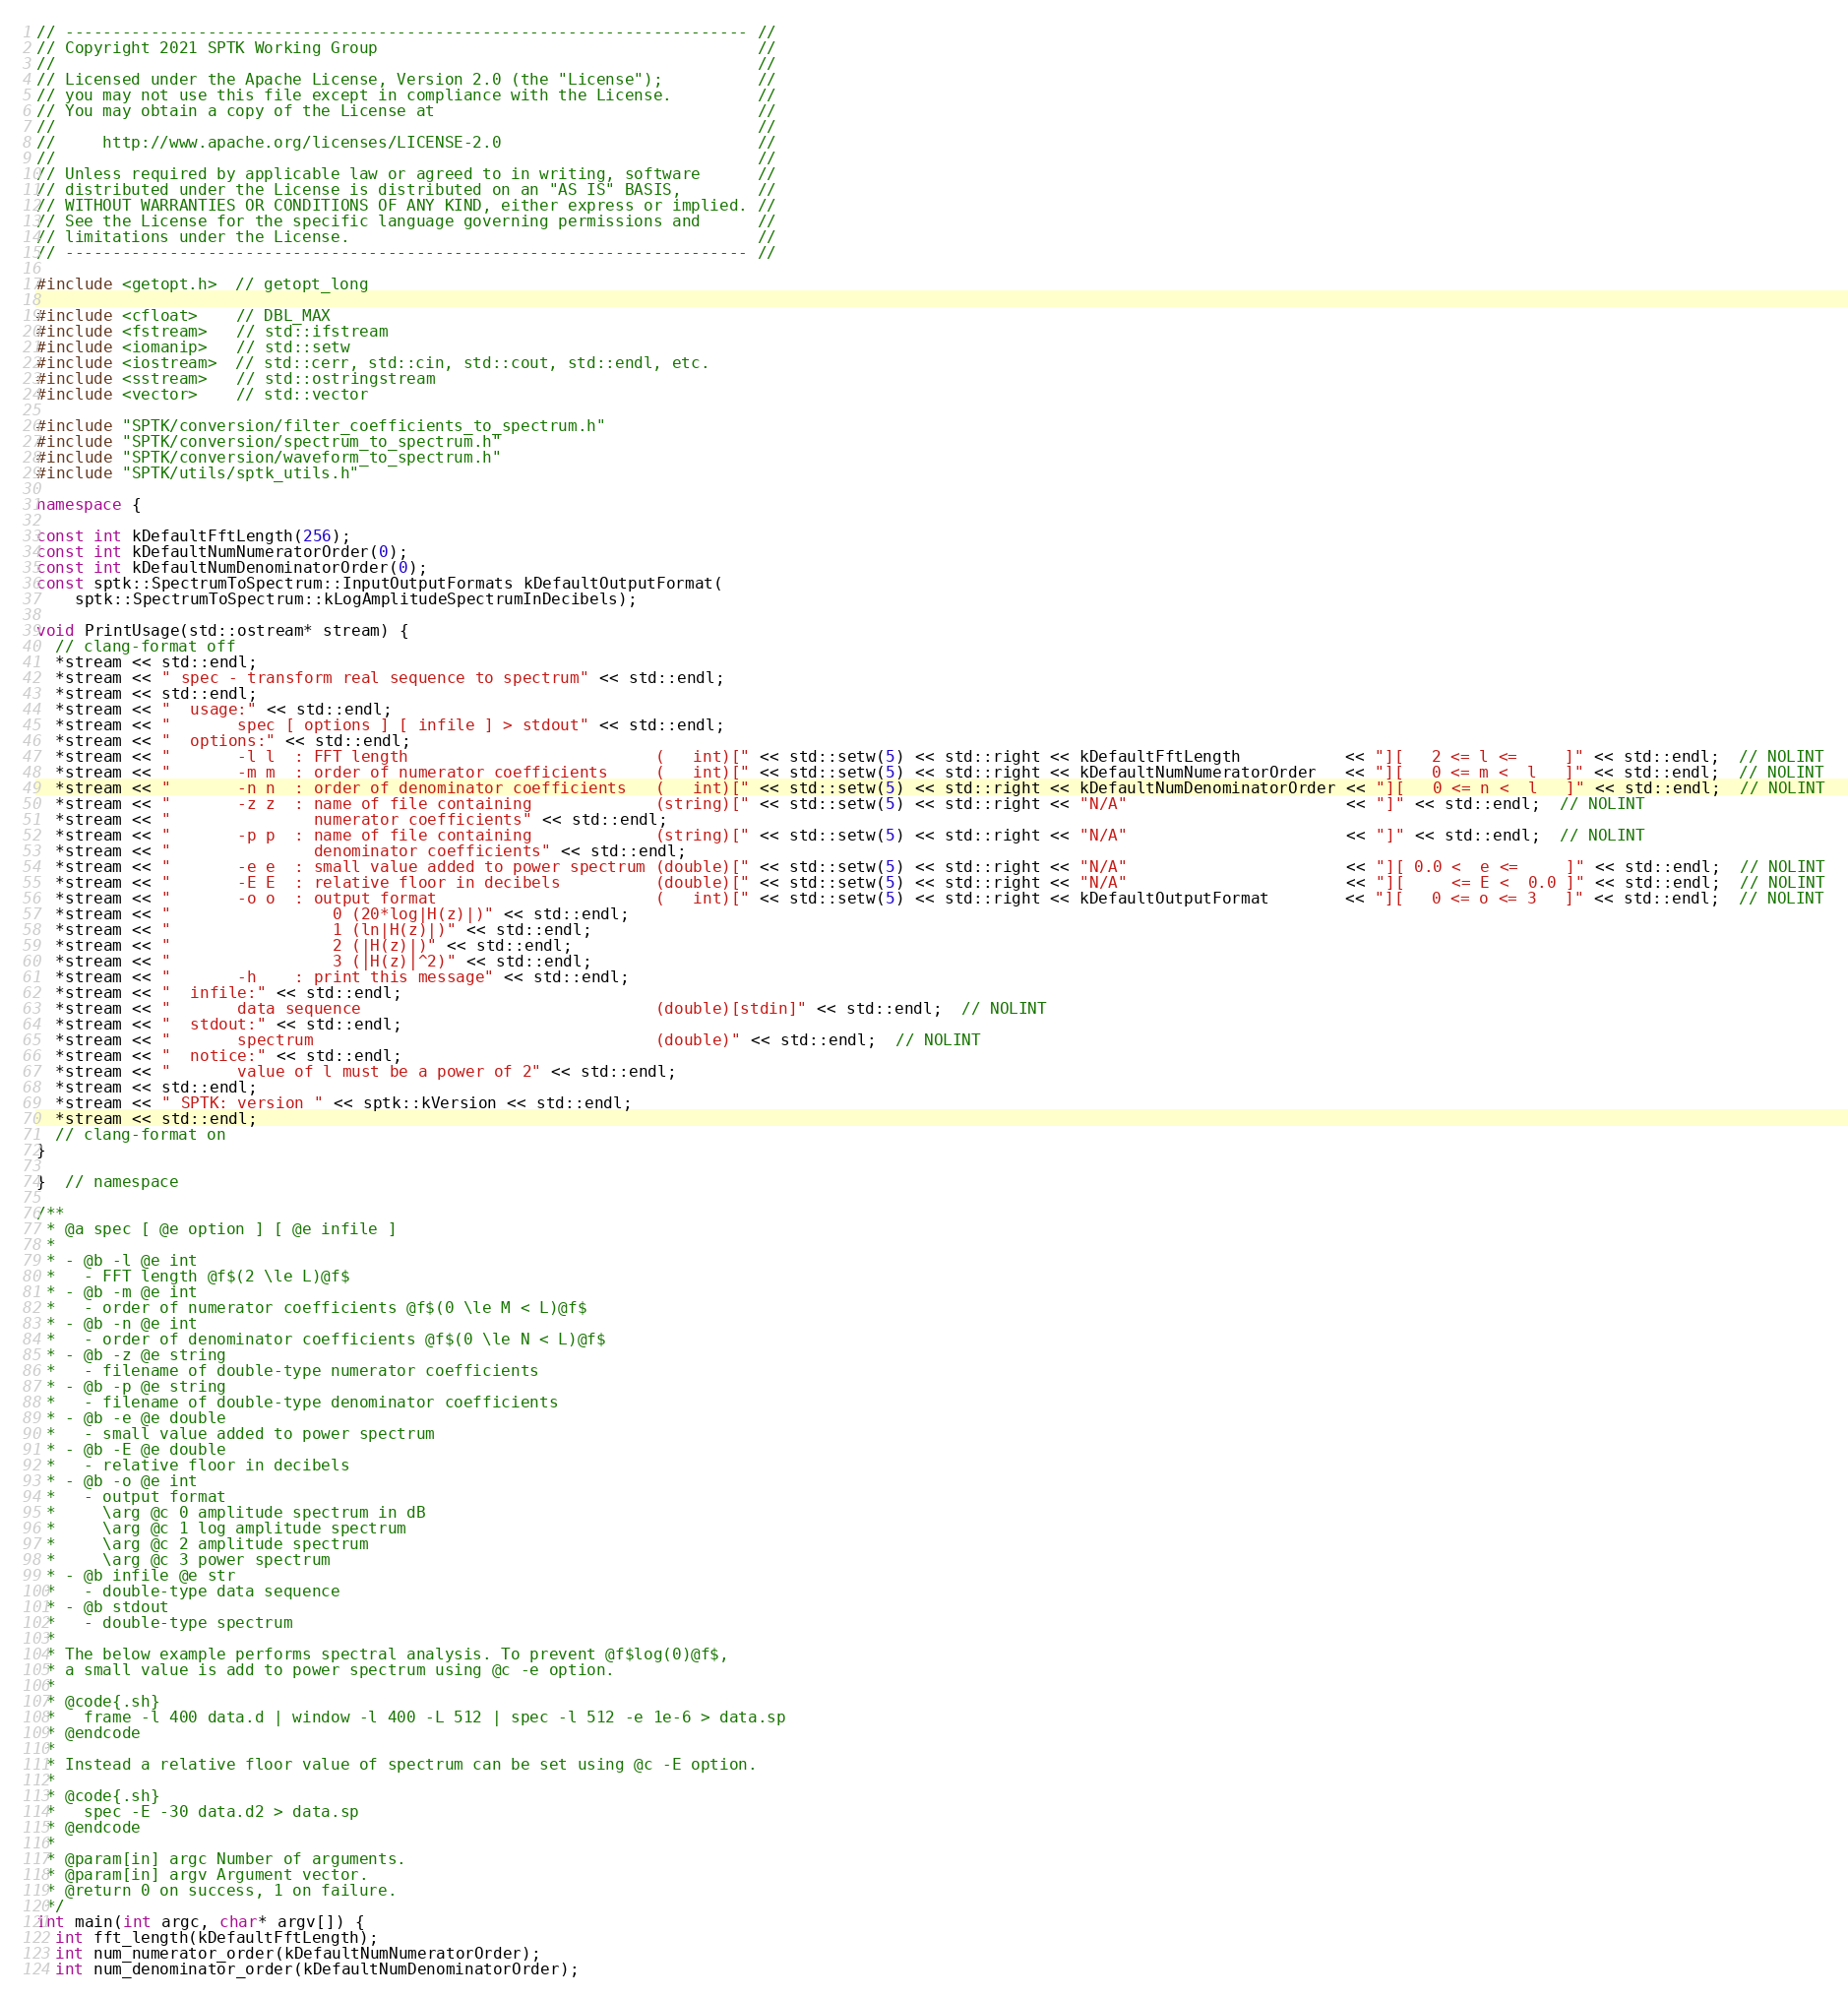Convert code to text. <code><loc_0><loc_0><loc_500><loc_500><_C++_>// ------------------------------------------------------------------------ //
// Copyright 2021 SPTK Working Group                                        //
//                                                                          //
// Licensed under the Apache License, Version 2.0 (the "License");          //
// you may not use this file except in compliance with the License.         //
// You may obtain a copy of the License at                                  //
//                                                                          //
//     http://www.apache.org/licenses/LICENSE-2.0                           //
//                                                                          //
// Unless required by applicable law or agreed to in writing, software      //
// distributed under the License is distributed on an "AS IS" BASIS,        //
// WITHOUT WARRANTIES OR CONDITIONS OF ANY KIND, either express or implied. //
// See the License for the specific language governing permissions and      //
// limitations under the License.                                           //
// ------------------------------------------------------------------------ //

#include <getopt.h>  // getopt_long

#include <cfloat>    // DBL_MAX
#include <fstream>   // std::ifstream
#include <iomanip>   // std::setw
#include <iostream>  // std::cerr, std::cin, std::cout, std::endl, etc.
#include <sstream>   // std::ostringstream
#include <vector>    // std::vector

#include "SPTK/conversion/filter_coefficients_to_spectrum.h"
#include "SPTK/conversion/spectrum_to_spectrum.h"
#include "SPTK/conversion/waveform_to_spectrum.h"
#include "SPTK/utils/sptk_utils.h"

namespace {

const int kDefaultFftLength(256);
const int kDefaultNumNumeratorOrder(0);
const int kDefaultNumDenominatorOrder(0);
const sptk::SpectrumToSpectrum::InputOutputFormats kDefaultOutputFormat(
    sptk::SpectrumToSpectrum::kLogAmplitudeSpectrumInDecibels);

void PrintUsage(std::ostream* stream) {
  // clang-format off
  *stream << std::endl;
  *stream << " spec - transform real sequence to spectrum" << std::endl;
  *stream << std::endl;
  *stream << "  usage:" << std::endl;
  *stream << "       spec [ options ] [ infile ] > stdout" << std::endl;
  *stream << "  options:" << std::endl;
  *stream << "       -l l  : FFT length                          (   int)[" << std::setw(5) << std::right << kDefaultFftLength           << "][   2 <= l <=     ]" << std::endl;  // NOLINT
  *stream << "       -m m  : order of numerator coefficients     (   int)[" << std::setw(5) << std::right << kDefaultNumNumeratorOrder   << "][   0 <= m <  l   ]" << std::endl;  // NOLINT
  *stream << "       -n n  : order of denominator coefficients   (   int)[" << std::setw(5) << std::right << kDefaultNumDenominatorOrder << "][   0 <= n <  l   ]" << std::endl;  // NOLINT
  *stream << "       -z z  : name of file containing             (string)[" << std::setw(5) << std::right << "N/A"                       << "]" << std::endl;  // NOLINT
  *stream << "               numerator coefficients" << std::endl;
  *stream << "       -p p  : name of file containing             (string)[" << std::setw(5) << std::right << "N/A"                       << "]" << std::endl;  // NOLINT
  *stream << "               denominator coefficients" << std::endl;
  *stream << "       -e e  : small value added to power spectrum (double)[" << std::setw(5) << std::right << "N/A"                       << "][ 0.0 <  e <=     ]" << std::endl;  // NOLINT
  *stream << "       -E E  : relative floor in decibels          (double)[" << std::setw(5) << std::right << "N/A"                       << "][     <= E <  0.0 ]" << std::endl;  // NOLINT
  *stream << "       -o o  : output format                       (   int)[" << std::setw(5) << std::right << kDefaultOutputFormat        << "][   0 <= o <= 3   ]" << std::endl;  // NOLINT
  *stream << "                 0 (20*log|H(z)|)" << std::endl;
  *stream << "                 1 (ln|H(z)|)" << std::endl;
  *stream << "                 2 (|H(z)|)" << std::endl;
  *stream << "                 3 (|H(z)|^2)" << std::endl;
  *stream << "       -h    : print this message" << std::endl;
  *stream << "  infile:" << std::endl;
  *stream << "       data sequence                               (double)[stdin]" << std::endl;  // NOLINT
  *stream << "  stdout:" << std::endl;
  *stream << "       spectrum                                    (double)" << std::endl;  // NOLINT
  *stream << "  notice:" << std::endl;
  *stream << "       value of l must be a power of 2" << std::endl;
  *stream << std::endl;
  *stream << " SPTK: version " << sptk::kVersion << std::endl;
  *stream << std::endl;
  // clang-format on
}

}  // namespace

/**
 * @a spec [ @e option ] [ @e infile ]
 *
 * - @b -l @e int
 *   - FFT length @f$(2 \le L)@f$
 * - @b -m @e int
 *   - order of numerator coefficients @f$(0 \le M < L)@f$
 * - @b -n @e int
 *   - order of denominator coefficients @f$(0 \le N < L)@f$
 * - @b -z @e string
 *   - filename of double-type numerator coefficients
 * - @b -p @e string
 *   - filename of double-type denominator coefficients
 * - @b -e @e double
 *   - small value added to power spectrum
 * - @b -E @e double
 *   - relative floor in decibels
 * - @b -o @e int
 *   - output format
 *     \arg @c 0 amplitude spectrum in dB
 *     \arg @c 1 log amplitude spectrum
 *     \arg @c 2 amplitude spectrum
 *     \arg @c 3 power spectrum
 * - @b infile @e str
 *   - double-type data sequence
 * - @b stdout
 *   - double-type spectrum
 *
 * The below example performs spectral analysis. To prevent @f$log(0)@f$,
 * a small value is add to power spectrum using @c -e option.
 *
 * @code{.sh}
 *   frame -l 400 data.d | window -l 400 -L 512 | spec -l 512 -e 1e-6 > data.sp
 * @endcode
 *
 * Instead a relative floor value of spectrum can be set using @c -E option.
 *
 * @code{.sh}
 *   spec -E -30 data.d2 > data.sp
 * @endcode
 *
 * @param[in] argc Number of arguments.
 * @param[in] argv Argument vector.
 * @return 0 on success, 1 on failure.
 */
int main(int argc, char* argv[]) {
  int fft_length(kDefaultFftLength);
  int num_numerator_order(kDefaultNumNumeratorOrder);
  int num_denominator_order(kDefaultNumDenominatorOrder);</code> 